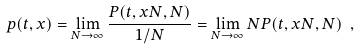Convert formula to latex. <formula><loc_0><loc_0><loc_500><loc_500>p ( t , x ) = \lim _ { N \to \infty } \frac { P ( t , x N , N ) } { 1 / N } = \lim _ { N \to \infty } N P ( t , x N , N ) \ ,</formula> 